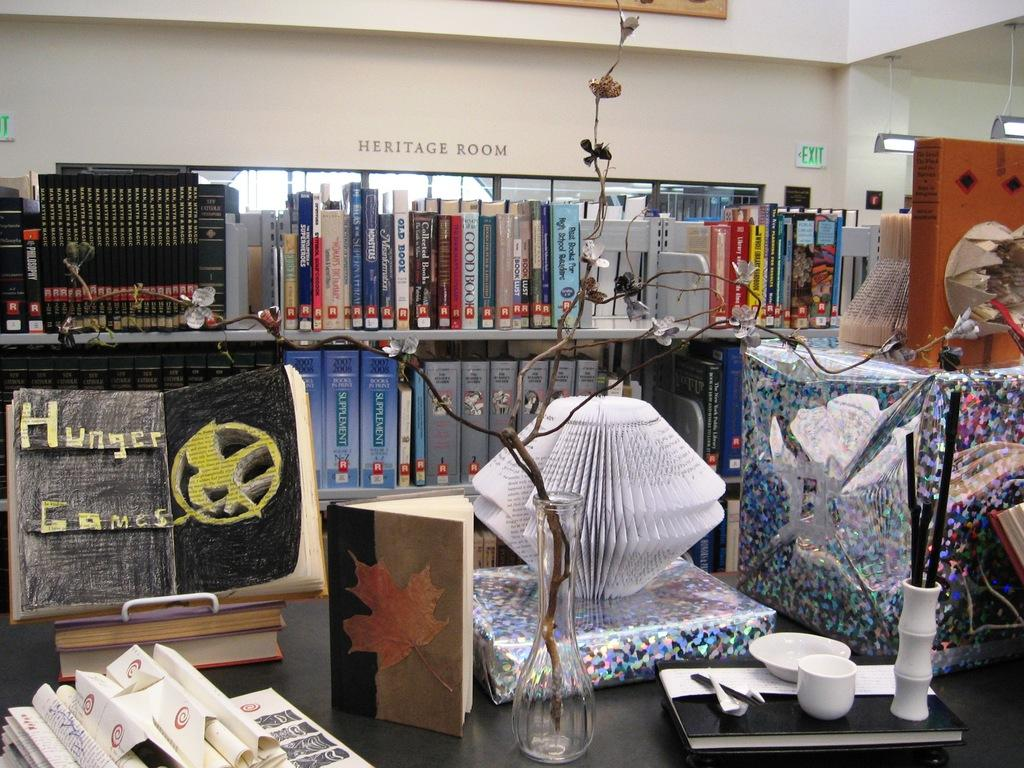Provide a one-sentence caption for the provided image. A heritage room full of books with the letter R on them. 